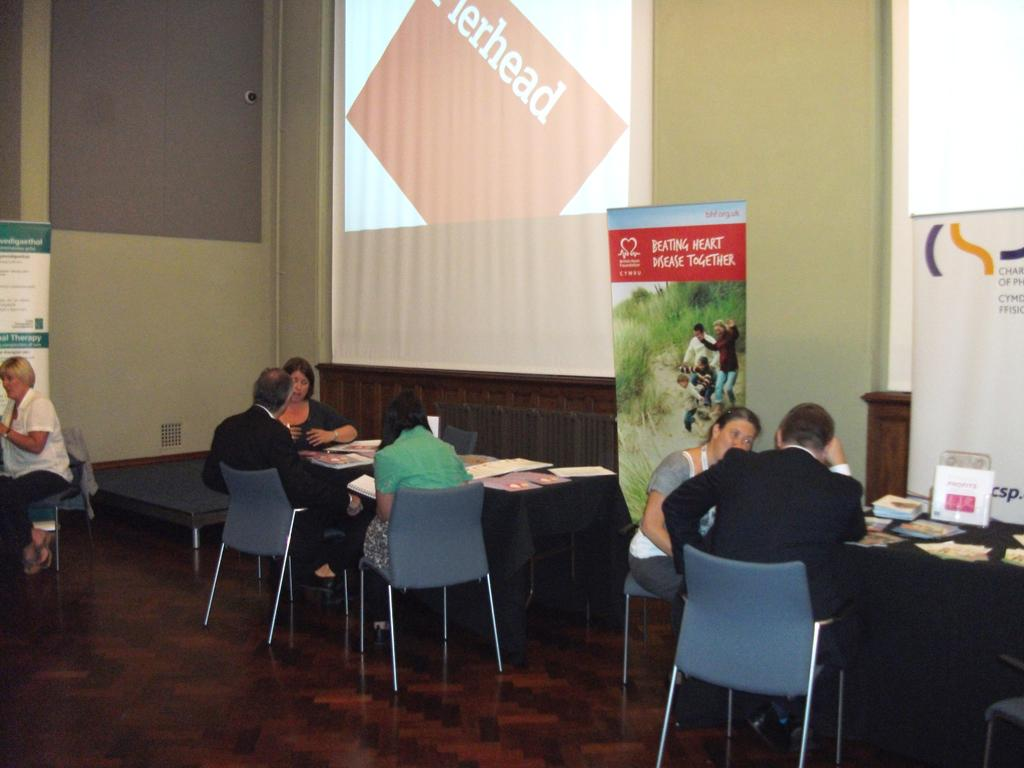What type of setting is depicted in the image? The image is an indoor scene. What are the people in the image doing? The people are sitting on chairs. What objects are in front of the chairs? There are tables in front of the chairs. What is on the tables? Papers are present on the tables. What can be seen attached to the wall in the image? There are screens attached to a wall. What additional decorative elements are visible in the image? Banners are visible in the image. How does the son contribute to the work being done in the image? There is no mention of a son or any work being done in the image. The image primarily features people sitting on chairs with tables, papers, and screens present. 